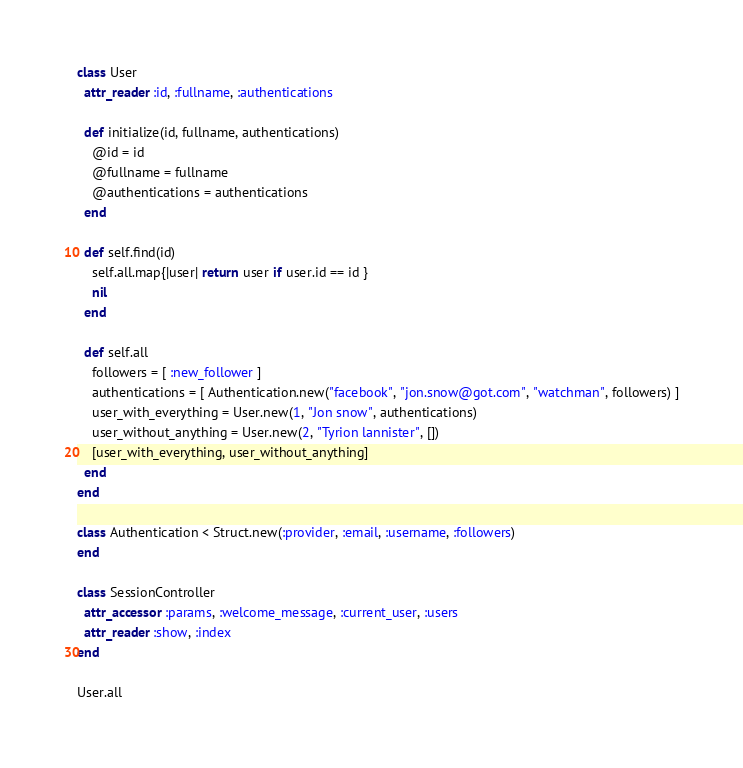Convert code to text. <code><loc_0><loc_0><loc_500><loc_500><_Ruby_>class User
  attr_reader :id, :fullname, :authentications

  def initialize(id, fullname, authentications)
    @id = id
    @fullname = fullname
    @authentications = authentications
  end

  def self.find(id)
    self.all.map{|user| return user if user.id == id }
    nil
  end

  def self.all
    followers = [ :new_follower ]
    authentications = [ Authentication.new("facebook", "jon.snow@got.com", "watchman", followers) ]
    user_with_everything = User.new(1, "Jon snow", authentications)
    user_without_anything = User.new(2, "Tyrion lannister", [])
    [user_with_everything, user_without_anything]
  end
end

class Authentication < Struct.new(:provider, :email, :username, :followers)
end

class SessionController
  attr_accessor :params, :welcome_message, :current_user, :users
  attr_reader :show, :index
end

User.all
</code> 